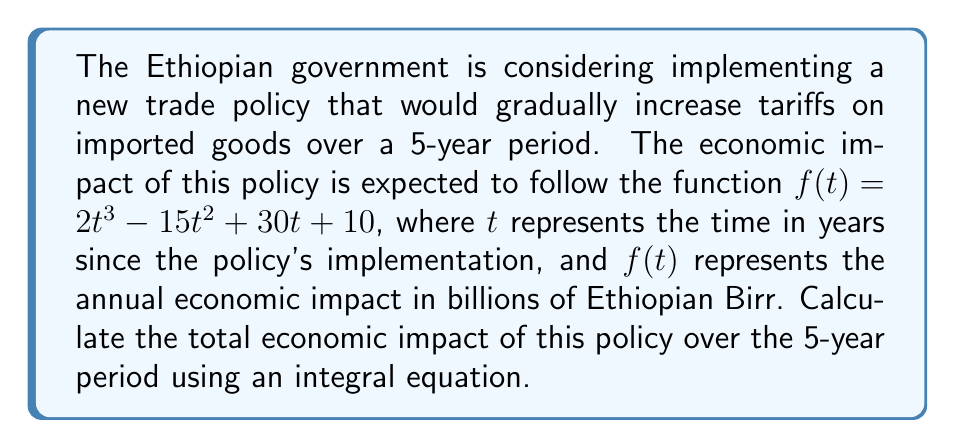Show me your answer to this math problem. To calculate the total economic impact over the 5-year period, we need to integrate the given function $f(t)$ from $t=0$ to $t=5$. This can be done using the following steps:

1. Set up the integral equation:
   $$\int_0^5 (2t^3 - 15t^2 + 30t + 10) dt$$

2. Integrate each term:
   $$\left[\frac{1}{2}t^4 - 5t^3 + 15t^2 + 10t\right]_0^5$$

3. Evaluate the integral at the upper and lower bounds:
   $$\left(\frac{1}{2}(5^4) - 5(5^3) + 15(5^2) + 10(5)\right) - \left(\frac{1}{2}(0^4) - 5(0^3) + 15(0^2) + 10(0)\right)$$

4. Simplify:
   $$\left(312.5 - 625 + 375 + 50\right) - (0)$$
   $$= 112.5$$

Therefore, the total economic impact over the 5-year period is 112.5 billion Ethiopian Birr.
Answer: 112.5 billion Ethiopian Birr 